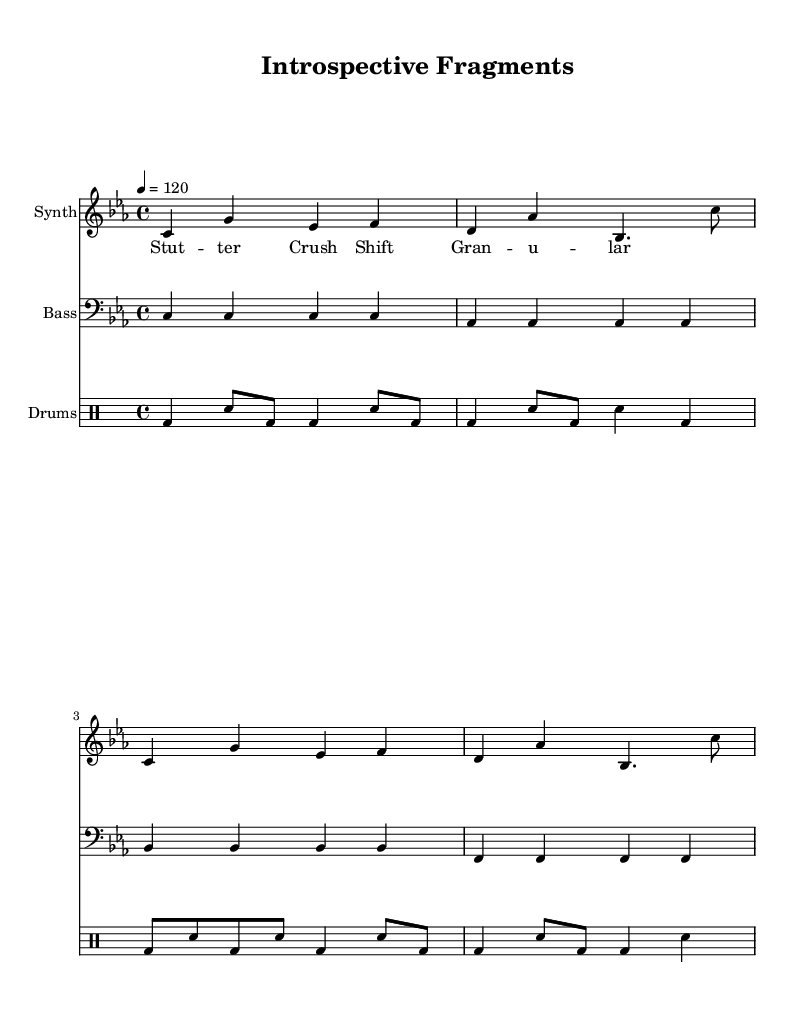What is the key signature of this music? The key signature shown in the music is C minor, indicated by three flats.
Answer: C minor What is the time signature of this piece? The time signature is depicted as 4/4, which means there are four beats in a measure and the quarter note receives one beat.
Answer: 4/4 What is the tempo marking of this score? The tempo marking indicates a speed of 120 beats per minute, which gives a moderate paced feel to the piece.
Answer: 120 What instruments are indicated in the score? The score lists four instruments: Synth, Bass, and Drums, which are well-suited for electronic music.
Answer: Synth, Bass, Drums How many measures are present in the synth part? The synth part consists of four measures, which can be counted from the musical notation provided.
Answer: 4 What effect do the lyrics suggest in the piece? The lyrics point towards glitch effects such as "Stutter," "Crush," "Shift," and "Granular," which reflect the themes of fragmentation and introspection.
Answer: Stutter, Crush, Shift, Granular How does the bass line relate to the synth melody? The bass line provides a continuous foundation in C minor, while the synth melody often contrasts and interacts with it, creating depth characteristic of electronic music.
Answer: Foundation 